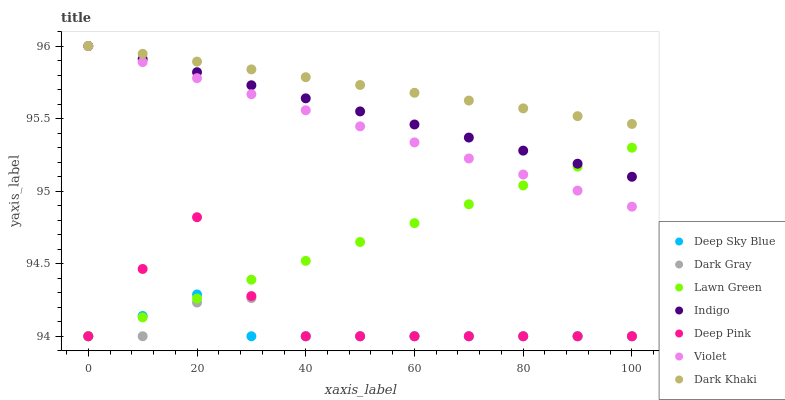Does Deep Sky Blue have the minimum area under the curve?
Answer yes or no. Yes. Does Dark Khaki have the maximum area under the curve?
Answer yes or no. Yes. Does Deep Pink have the minimum area under the curve?
Answer yes or no. No. Does Deep Pink have the maximum area under the curve?
Answer yes or no. No. Is Violet the smoothest?
Answer yes or no. Yes. Is Deep Pink the roughest?
Answer yes or no. Yes. Is Indigo the smoothest?
Answer yes or no. No. Is Indigo the roughest?
Answer yes or no. No. Does Lawn Green have the lowest value?
Answer yes or no. Yes. Does Indigo have the lowest value?
Answer yes or no. No. Does Violet have the highest value?
Answer yes or no. Yes. Does Deep Pink have the highest value?
Answer yes or no. No. Is Dark Gray less than Violet?
Answer yes or no. Yes. Is Indigo greater than Deep Pink?
Answer yes or no. Yes. Does Deep Pink intersect Lawn Green?
Answer yes or no. Yes. Is Deep Pink less than Lawn Green?
Answer yes or no. No. Is Deep Pink greater than Lawn Green?
Answer yes or no. No. Does Dark Gray intersect Violet?
Answer yes or no. No. 